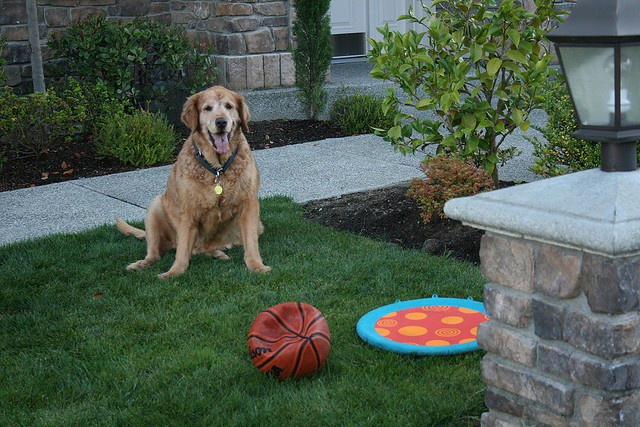Describe the objects in this image and their specific colors. I can see dog in black, gray, and darkgray tones, frisbee in black, salmon, lightblue, and orange tones, and sports ball in black, maroon, and brown tones in this image. 